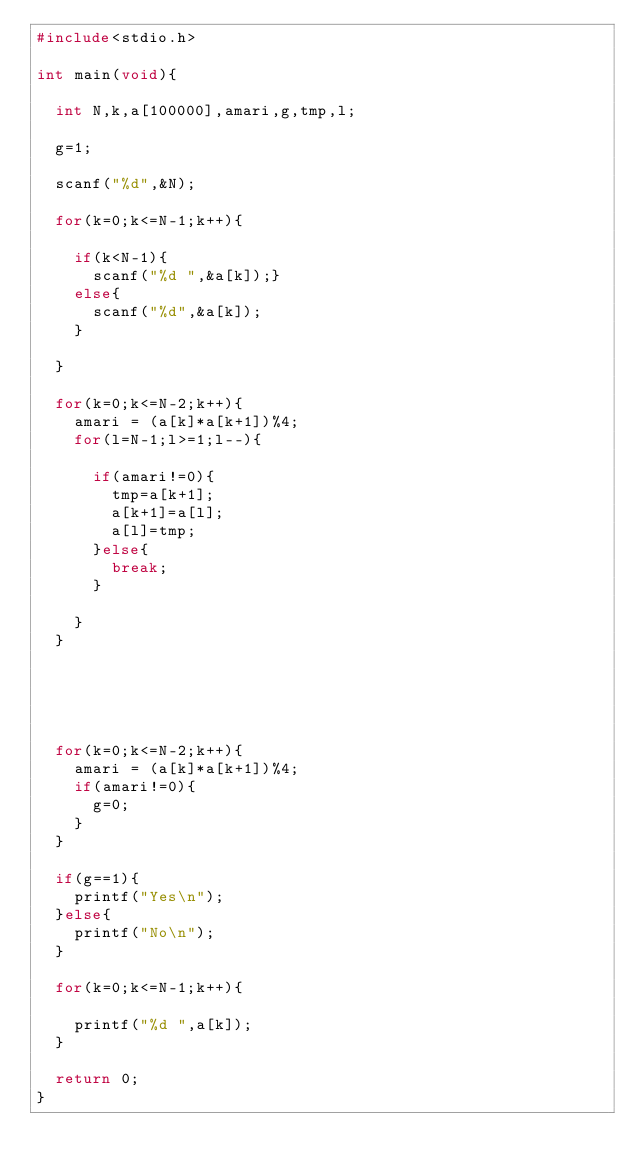<code> <loc_0><loc_0><loc_500><loc_500><_C++_>#include<stdio.h>

int main(void){
	
	int N,k,a[100000],amari,g,tmp,l;
	
	g=1;
	
	scanf("%d",&N);
	
	for(k=0;k<=N-1;k++){
		
		if(k<N-1){
			scanf("%d ",&a[k]);}
		else{
			scanf("%d",&a[k]);
		}
		
	}
	
	for(k=0;k<=N-2;k++){
		amari = (a[k]*a[k+1])%4;
		for(l=N-1;l>=1;l--){
			
			if(amari!=0){
				tmp=a[k+1];
				a[k+1]=a[l];
				a[l]=tmp;
			}else{
				break;
			}
			
		}
	}
	
	
	
	
	
	for(k=0;k<=N-2;k++){
		amari = (a[k]*a[k+1])%4;
		if(amari!=0){
			g=0;
		}
	}
	
	if(g==1){
		printf("Yes\n");
	}else{
		printf("No\n");
	}
	
	for(k=0;k<=N-1;k++){
		
		printf("%d ",a[k]);
	}
	
	return 0;
}
</code> 